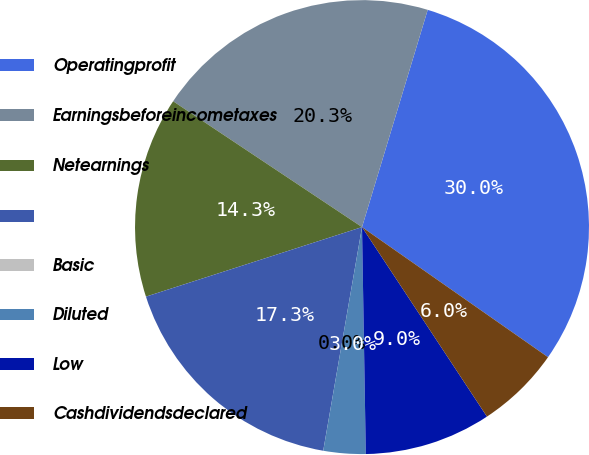Convert chart. <chart><loc_0><loc_0><loc_500><loc_500><pie_chart><fcel>Operatingprofit<fcel>Earningsbeforeincometaxes<fcel>Netearnings<fcel>Unnamed: 3<fcel>Basic<fcel>Diluted<fcel>Low<fcel>Cashdividendsdeclared<nl><fcel>30.04%<fcel>20.32%<fcel>14.31%<fcel>17.31%<fcel>0.0%<fcel>3.0%<fcel>9.01%<fcel>6.01%<nl></chart> 